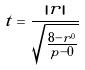<formula> <loc_0><loc_0><loc_500><loc_500>t = \frac { | r | } { \sqrt { \frac { 8 - r ^ { 0 } } { p - 0 } } }</formula> 